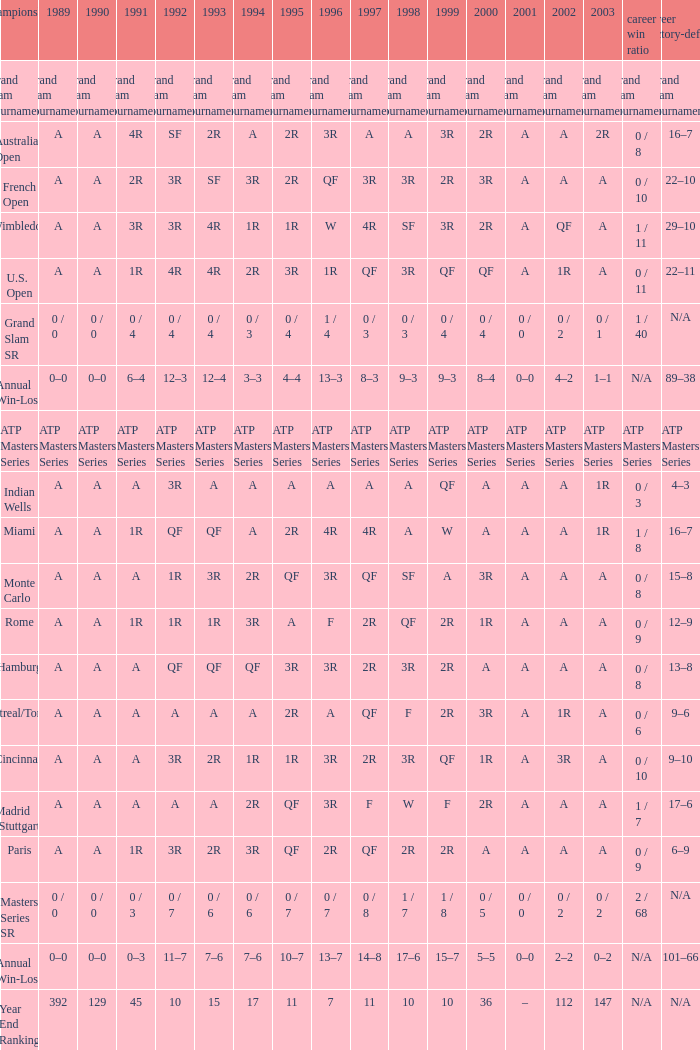What is the value in 1997 when the value in 1989 is A, 1995 is QF, 1996 is 3R and the career SR is 0 / 8? QF. 